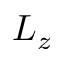<formula> <loc_0><loc_0><loc_500><loc_500>L _ { z }</formula> 